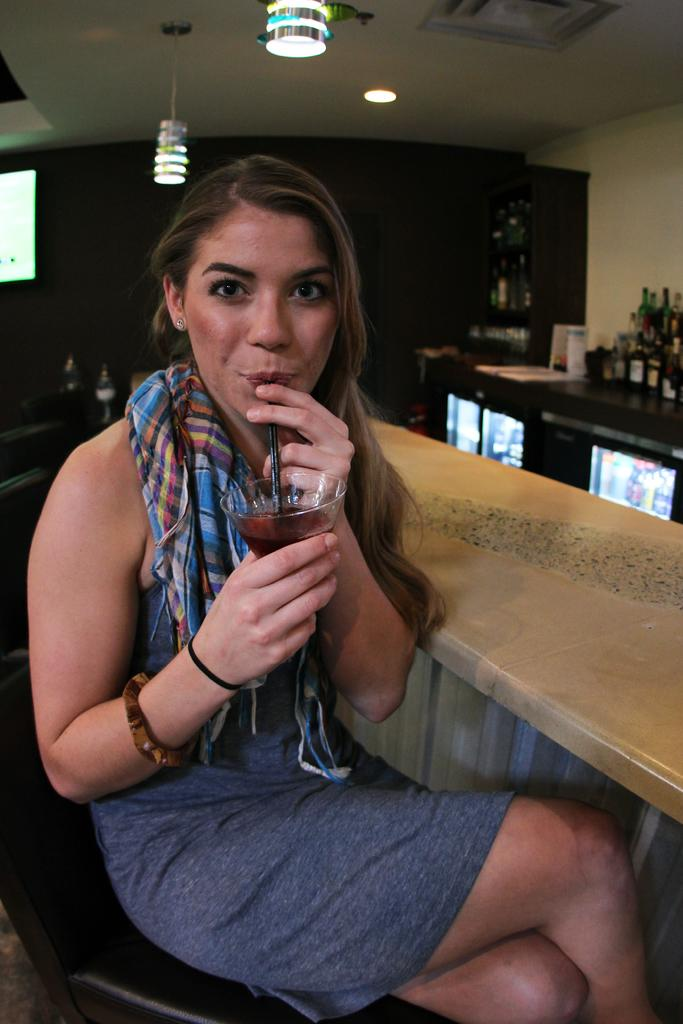What is the person in the image holding? The person is holding a glass in the image. What is inside the glass? The glass has a straw in it. What else can be seen in the image besides the person and the glass? There are bottles, lights, a wall, and other objects present in the image. How many pigs are crossing the bridge in the image? There are no pigs or bridges present in the image. Are there any bikes visible in the image? There is no mention of bikes in the provided facts, so we cannot determine if they are present in the image. 